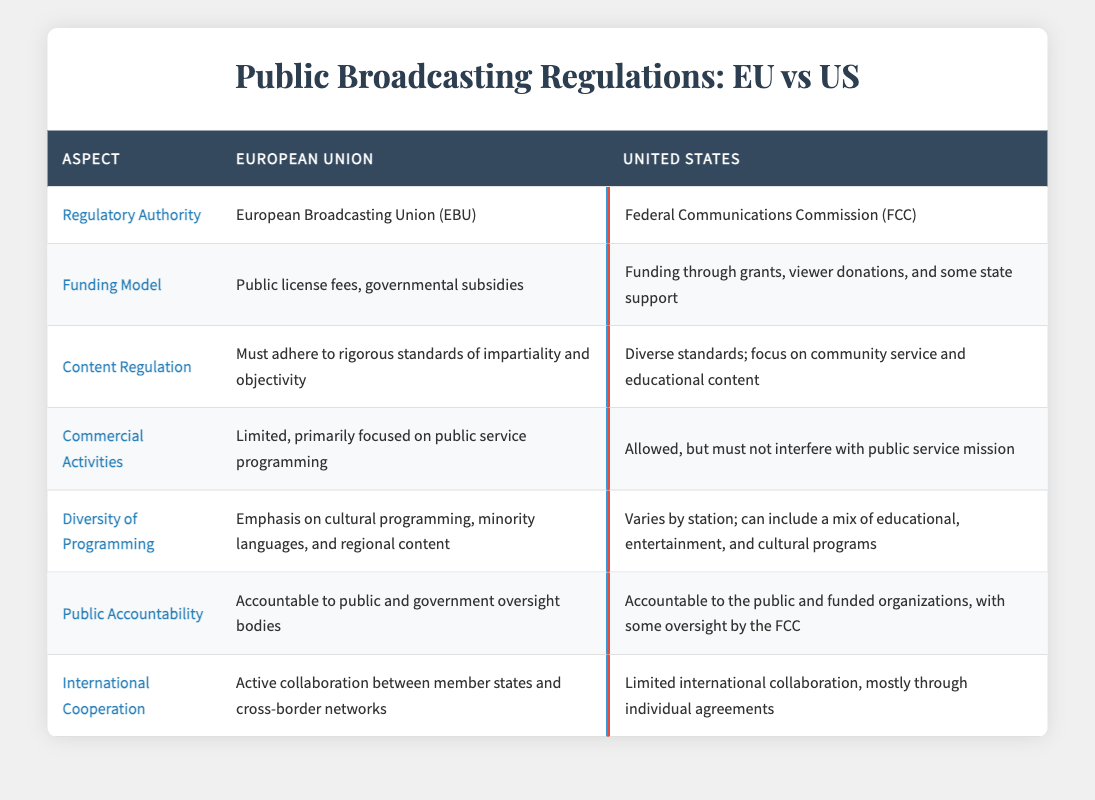What is the regulatory authority for public broadcasting in the European Union? The table states that the regulatory authority in the EU is the European Broadcasting Union (EBU).
Answer: European Broadcasting Union (EBU) How is public broadcasting funded in the United States? According to the table, funding in the US comes from grants, viewer donations, and some state support.
Answer: Grants, viewer donations, and some state support Do both the EU and the US require content regulation for public broadcasting? Yes, both regions have regulations. The EU has rigorous standards for impartiality, while the US has a diverse approach focused on community service.
Answer: Yes Which region emphasizes cultural programming more in their broadcasting regulations? The table indicates that the EU emphasizes cultural programming, minority languages, and regional content, while the US varies by station.
Answer: European Union Is international cooperation for public broadcasting more active in the EU than in the US? Yes, the table highlights that the EU engages in active collaboration among member states and networks, whereas the US has limited collaboration through individual agreements.
Answer: Yes What is the main difference in accountability for public broadcasting between the EU and the US? The EU holds its public broadcasting accountable to public and government oversight bodies, whereas the US is accountable to the public and funded organizations, with some oversight by the FCC.
Answer: The EU is accountable to public and government oversight bodies, while the US is accountable to public and funded organizations How many funding models are mentioned for public broadcasting in the EU? The table lists one funding model for the EU, which includes public license fees and governmental subsidies together.
Answer: One funding model Which aspect of broadcasting regulation has more strict standards in the EU compared to the US? Content regulation in the EU is described as must adhere to rigorous standards, unlike the US, which has diverse, less stringent standards.
Answer: Content regulation Is it true that the US does not allow any commercial activities in public broadcasting? False, the table states that commercial activities are allowed in the US, as long as they do not interfere with the public service mission.
Answer: False 